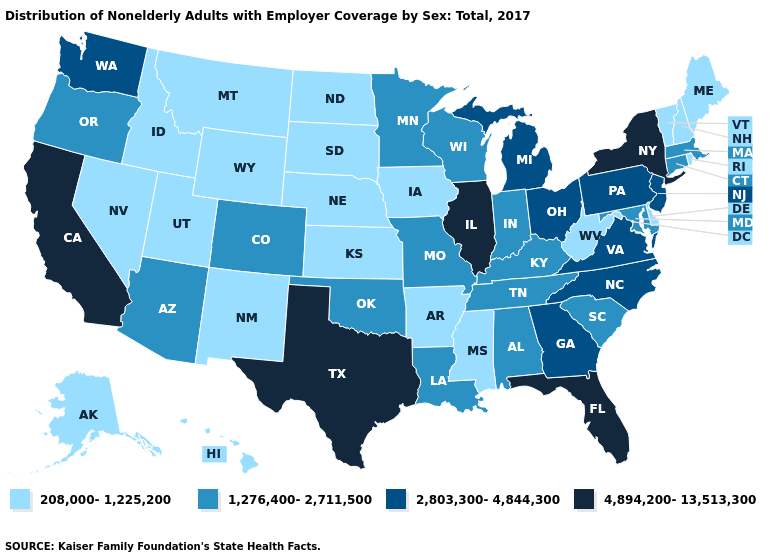Does California have the highest value in the USA?
Give a very brief answer. Yes. Among the states that border Michigan , which have the highest value?
Keep it brief. Ohio. What is the value of California?
Write a very short answer. 4,894,200-13,513,300. Does the map have missing data?
Answer briefly. No. Name the states that have a value in the range 208,000-1,225,200?
Quick response, please. Alaska, Arkansas, Delaware, Hawaii, Idaho, Iowa, Kansas, Maine, Mississippi, Montana, Nebraska, Nevada, New Hampshire, New Mexico, North Dakota, Rhode Island, South Dakota, Utah, Vermont, West Virginia, Wyoming. What is the value of Delaware?
Write a very short answer. 208,000-1,225,200. Name the states that have a value in the range 1,276,400-2,711,500?
Answer briefly. Alabama, Arizona, Colorado, Connecticut, Indiana, Kentucky, Louisiana, Maryland, Massachusetts, Minnesota, Missouri, Oklahoma, Oregon, South Carolina, Tennessee, Wisconsin. Does Michigan have the highest value in the USA?
Give a very brief answer. No. Does Ohio have the lowest value in the USA?
Keep it brief. No. What is the lowest value in the MidWest?
Give a very brief answer. 208,000-1,225,200. Which states have the lowest value in the USA?
Write a very short answer. Alaska, Arkansas, Delaware, Hawaii, Idaho, Iowa, Kansas, Maine, Mississippi, Montana, Nebraska, Nevada, New Hampshire, New Mexico, North Dakota, Rhode Island, South Dakota, Utah, Vermont, West Virginia, Wyoming. Name the states that have a value in the range 1,276,400-2,711,500?
Quick response, please. Alabama, Arizona, Colorado, Connecticut, Indiana, Kentucky, Louisiana, Maryland, Massachusetts, Minnesota, Missouri, Oklahoma, Oregon, South Carolina, Tennessee, Wisconsin. Among the states that border Pennsylvania , which have the highest value?
Write a very short answer. New York. Name the states that have a value in the range 2,803,300-4,844,300?
Write a very short answer. Georgia, Michigan, New Jersey, North Carolina, Ohio, Pennsylvania, Virginia, Washington. 